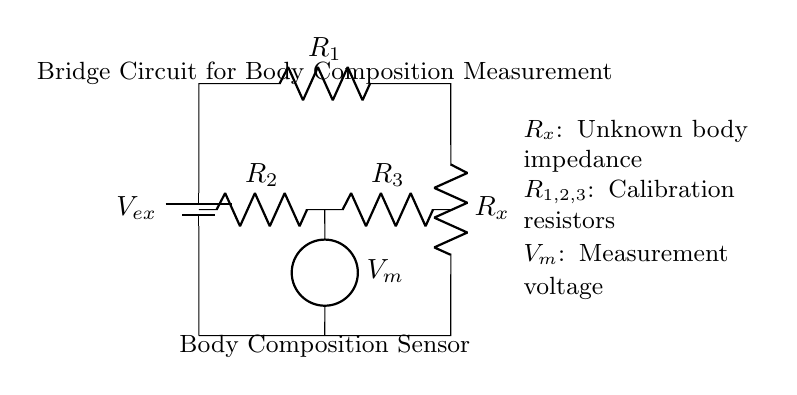What is the unknown impedance represented in the circuit? The unknown impedance is denoted as R_x in the circuit diagram. It is specifically labeled in the information provided about the components.
Answer: R_x What components are present in the circuit? The circuit diagram includes three resistors (R_1, R_2, R_3), an unknown impedance (R_x), a battery (V_ex), and a measurement device (V_m). Each component is labeled within the diagram.
Answer: R_1, R_2, R_3, R_x, V_ex, V_m What is the purpose of the battery in this circuit? The battery (V_ex) provides the necessary excitation voltage for the bridge circuit, enabling current to flow through the components and allowing for the measurement of body impedance.
Answer: Provide excitation voltage How is the measurement voltage obtained in the circuit? The measurement voltage (V_m) is taken across R_2 and R_3. This is where the voltage drop is measured, allowing the comparison of R_x against the known resistors in the circuit.
Answer: Voltage across R_2 and R_3 What is the role of the calibration resistors in this circuit? The calibration resistors (R_1, R_2, R_3) are used to create a balanced condition in the bridge circuit, which is essential for accurately determining the unknown impedance (R_x).
Answer: Create balance for measurement Which type of circuit is represented here? The circuit is a bridge circuit, specifically designed for measuring body composition by balancing known resistances against an unknown one.
Answer: Bridge circuit 